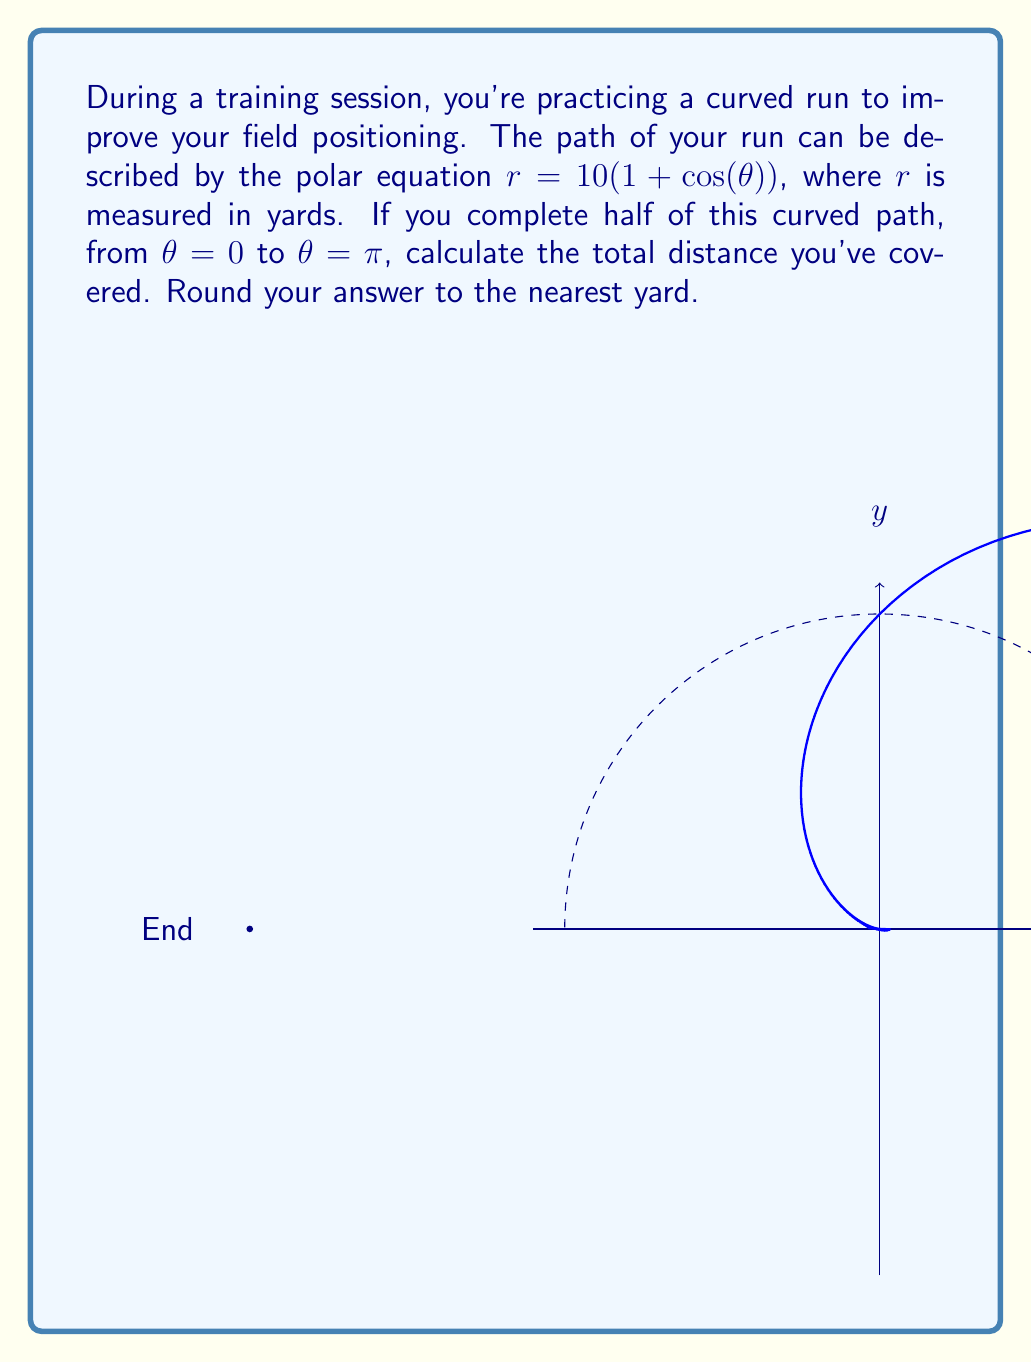Provide a solution to this math problem. Let's approach this step-by-step:

1) The formula for the arc length in polar coordinates is:

   $$L = \int_a^b \sqrt{r^2 + \left(\frac{dr}{d\theta}\right)^2} d\theta$$

2) We're given $r = 10(1 + \cos(\theta))$. We need to find $\frac{dr}{d\theta}$:

   $$\frac{dr}{d\theta} = 10(-\sin(\theta))$$

3) Substituting these into our arc length formula:

   $$L = \int_0^\pi \sqrt{(10(1 + \cos(\theta)))^2 + (10(-\sin(\theta)))^2} d\theta$$

4) Simplifying inside the square root:

   $$L = \int_0^\pi \sqrt{100(1 + \cos(\theta))^2 + 100\sin^2(\theta)} d\theta$$

5) Factoring out 100:

   $$L = 10\int_0^\pi \sqrt{(1 + \cos(\theta))^2 + \sin^2(\theta)} d\theta$$

6) Using the trigonometric identity $\sin^2(\theta) + \cos^2(\theta) = 1$, we can simplify:

   $$L = 10\int_0^\pi \sqrt{1 + 2\cos(\theta) + \cos^2(\theta) + \sin^2(\theta)} d\theta$$
   $$L = 10\int_0^\pi \sqrt{2 + 2\cos(\theta)} d\theta$$
   $$L = 10\int_0^\pi \sqrt{2(1 + \cos(\theta))} d\theta$$

7) This simplifies to:

   $$L = 10\sqrt{2}\int_0^\pi \sqrt{1 + \cos(\theta)} d\theta$$

8) This integral evaluates to:

   $$L = 10\sqrt{2} \cdot 2 = 20\sqrt{2}$$

9) Converting to yards and rounding to the nearest yard:

   $$20\sqrt{2} \approx 28.28 \approx 28 \text{ yards}$$
Answer: 28 yards 